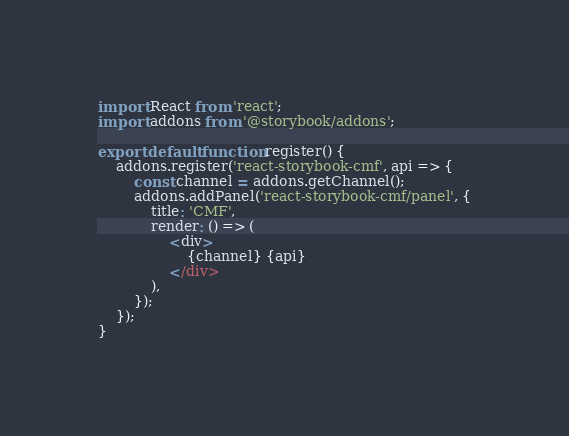Convert code to text. <code><loc_0><loc_0><loc_500><loc_500><_JavaScript_>import React from 'react';
import addons from '@storybook/addons';

export default function register() {
	addons.register('react-storybook-cmf', api => {
		const channel = addons.getChannel();
		addons.addPanel('react-storybook-cmf/panel', {
			title: 'CMF',
			render: () => (
				<div>
					{channel} {api}
				</div>
			),
		});
	});
}
</code> 